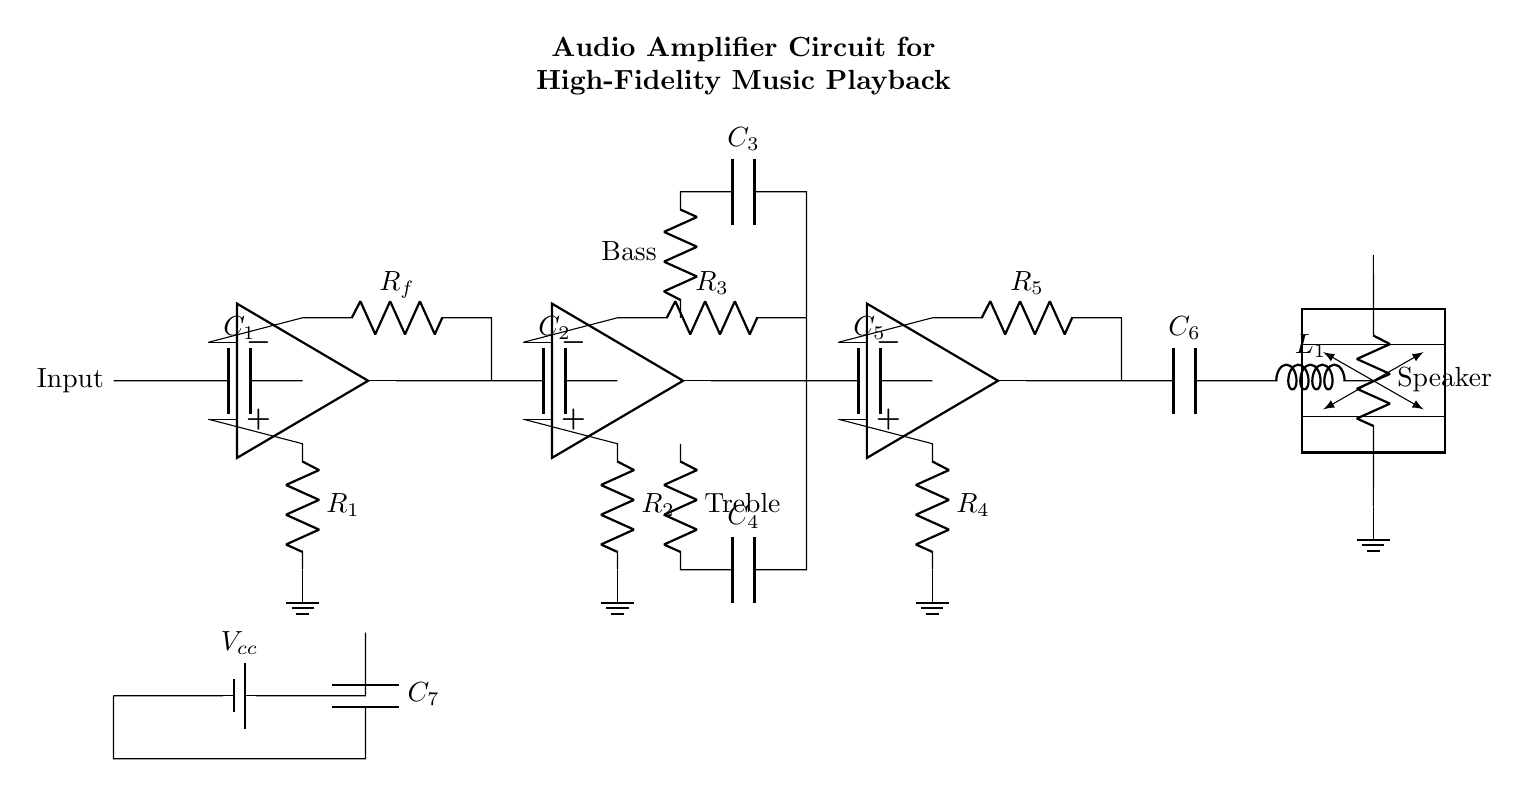What type of amplifier is shown in the circuit? The circuit is an audio amplifier designed for high-fidelity music playback, indicated by the presence of multiple stages including input, tone control, power amplification, and output.
Answer: Audio amplifier What does C1 do in the circuit? C1 is a capacitor connected at the input stage, which is used for coupling and blocking DC while allowing AC audio signals to pass through.
Answer: Coupling capacitor How many operational amplifiers are used in this circuit? The circuit contains three operational amplifiers, one in each stage: input, tone control, and power amplification.
Answer: Three What is the purpose of the resistors R1, R2, R3, R4, and R5? These resistors are used to form feedback and biasing networks, controlling gain and stability in their respective amplifier stages.
Answer: Gain and stability control What component is connected directly before the speaker? The component directly before the speaker is the inductor L1, which is used for filtering and protecting the speaker from DC signals.
Answer: Inductor What does the power supply voltage represent in the circuit? The power supply voltage labeled Vcc provides the necessary energy for all the amplifier stages to operate, which is crucial for amplifying audio signals.
Answer: Supply voltage What features does the tone control stage provide in this amplifier circuit? The tone control stage includes components that allow the adjustment of bass and treble frequencies, which enhances user control over the audio output.
Answer: Bass and treble adjustment 